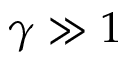<formula> <loc_0><loc_0><loc_500><loc_500>\gamma \gg 1</formula> 